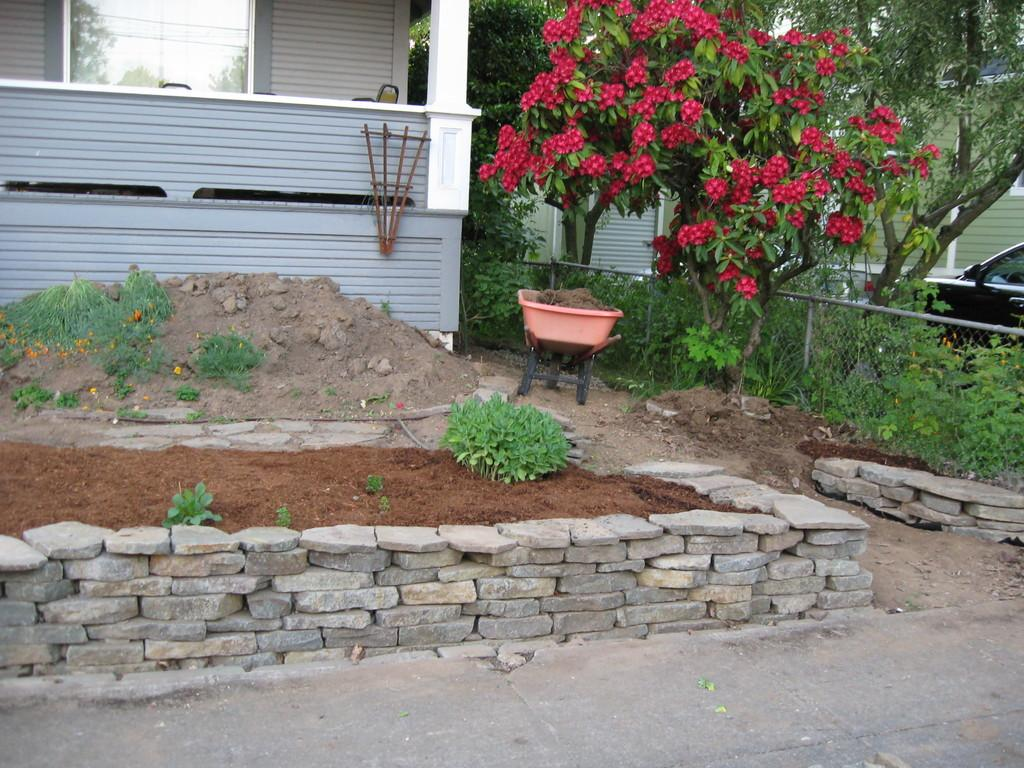What type of structures can be seen in the image? There are houses in the image. What type of vegetation is present in the image? There are plants, trees, and flowers in the image. What object can be seen holding items in the image? There is a tray in the image. What type of natural elements are present in the image? There are rocks and mud in the image. What type of apparel is being worn by the rocks in the image? There are no people or clothing present in the image, only rocks. Can you tell me how many pins are holding the flowers in the image? There are no pins present in the image; the flowers are not being held up by any pins. 